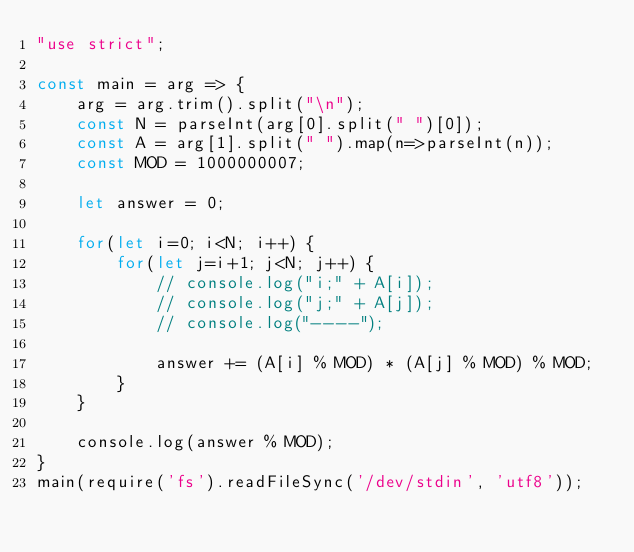Convert code to text. <code><loc_0><loc_0><loc_500><loc_500><_JavaScript_>"use strict";
    
const main = arg => {
    arg = arg.trim().split("\n");
    const N = parseInt(arg[0].split(" ")[0]);
    const A = arg[1].split(" ").map(n=>parseInt(n));
    const MOD = 1000000007;
    
    let answer = 0;
    
    for(let i=0; i<N; i++) {
        for(let j=i+1; j<N; j++) {
            // console.log("i;" + A[i]);
            // console.log("j;" + A[j]);
            // console.log("----");
            
            answer += (A[i] % MOD) * (A[j] % MOD) % MOD;
        }
    }
    
    console.log(answer % MOD);
}
main(require('fs').readFileSync('/dev/stdin', 'utf8'));</code> 